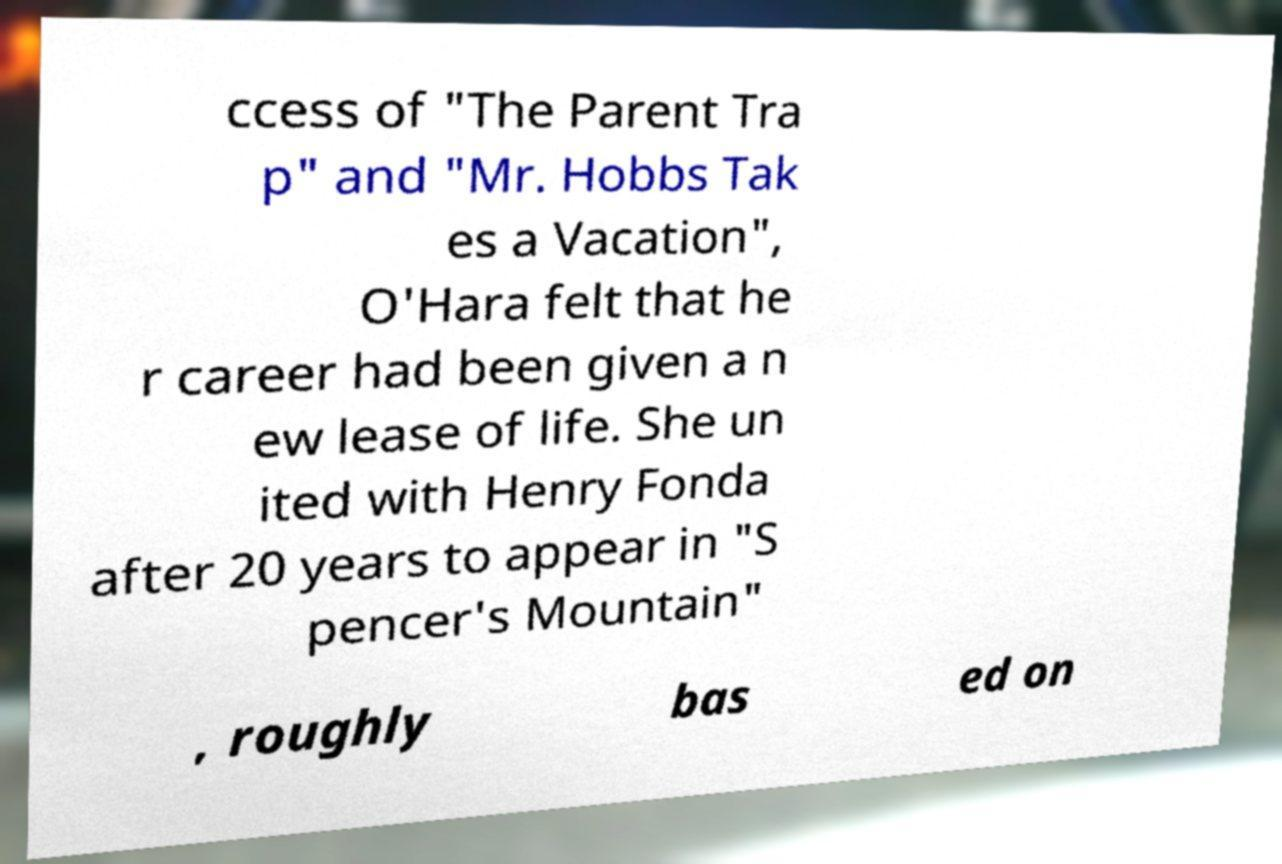Please read and relay the text visible in this image. What does it say? ccess of "The Parent Tra p" and "Mr. Hobbs Tak es a Vacation", O'Hara felt that he r career had been given a n ew lease of life. She un ited with Henry Fonda after 20 years to appear in "S pencer's Mountain" , roughly bas ed on 